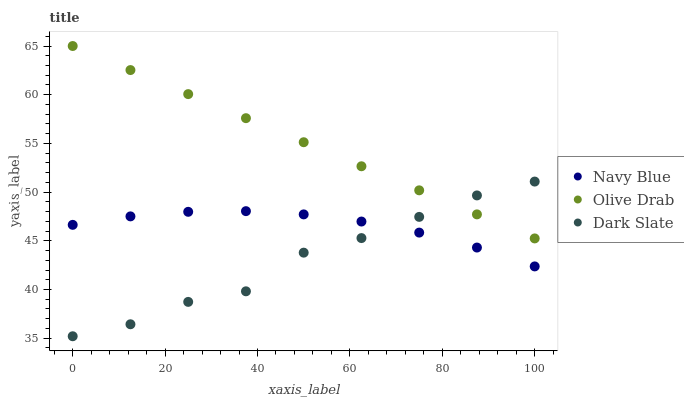Does Dark Slate have the minimum area under the curve?
Answer yes or no. Yes. Does Olive Drab have the maximum area under the curve?
Answer yes or no. Yes. Does Olive Drab have the minimum area under the curve?
Answer yes or no. No. Does Dark Slate have the maximum area under the curve?
Answer yes or no. No. Is Olive Drab the smoothest?
Answer yes or no. Yes. Is Dark Slate the roughest?
Answer yes or no. Yes. Is Dark Slate the smoothest?
Answer yes or no. No. Is Olive Drab the roughest?
Answer yes or no. No. Does Dark Slate have the lowest value?
Answer yes or no. Yes. Does Olive Drab have the lowest value?
Answer yes or no. No. Does Olive Drab have the highest value?
Answer yes or no. Yes. Does Dark Slate have the highest value?
Answer yes or no. No. Is Navy Blue less than Olive Drab?
Answer yes or no. Yes. Is Olive Drab greater than Navy Blue?
Answer yes or no. Yes. Does Olive Drab intersect Dark Slate?
Answer yes or no. Yes. Is Olive Drab less than Dark Slate?
Answer yes or no. No. Is Olive Drab greater than Dark Slate?
Answer yes or no. No. Does Navy Blue intersect Olive Drab?
Answer yes or no. No. 